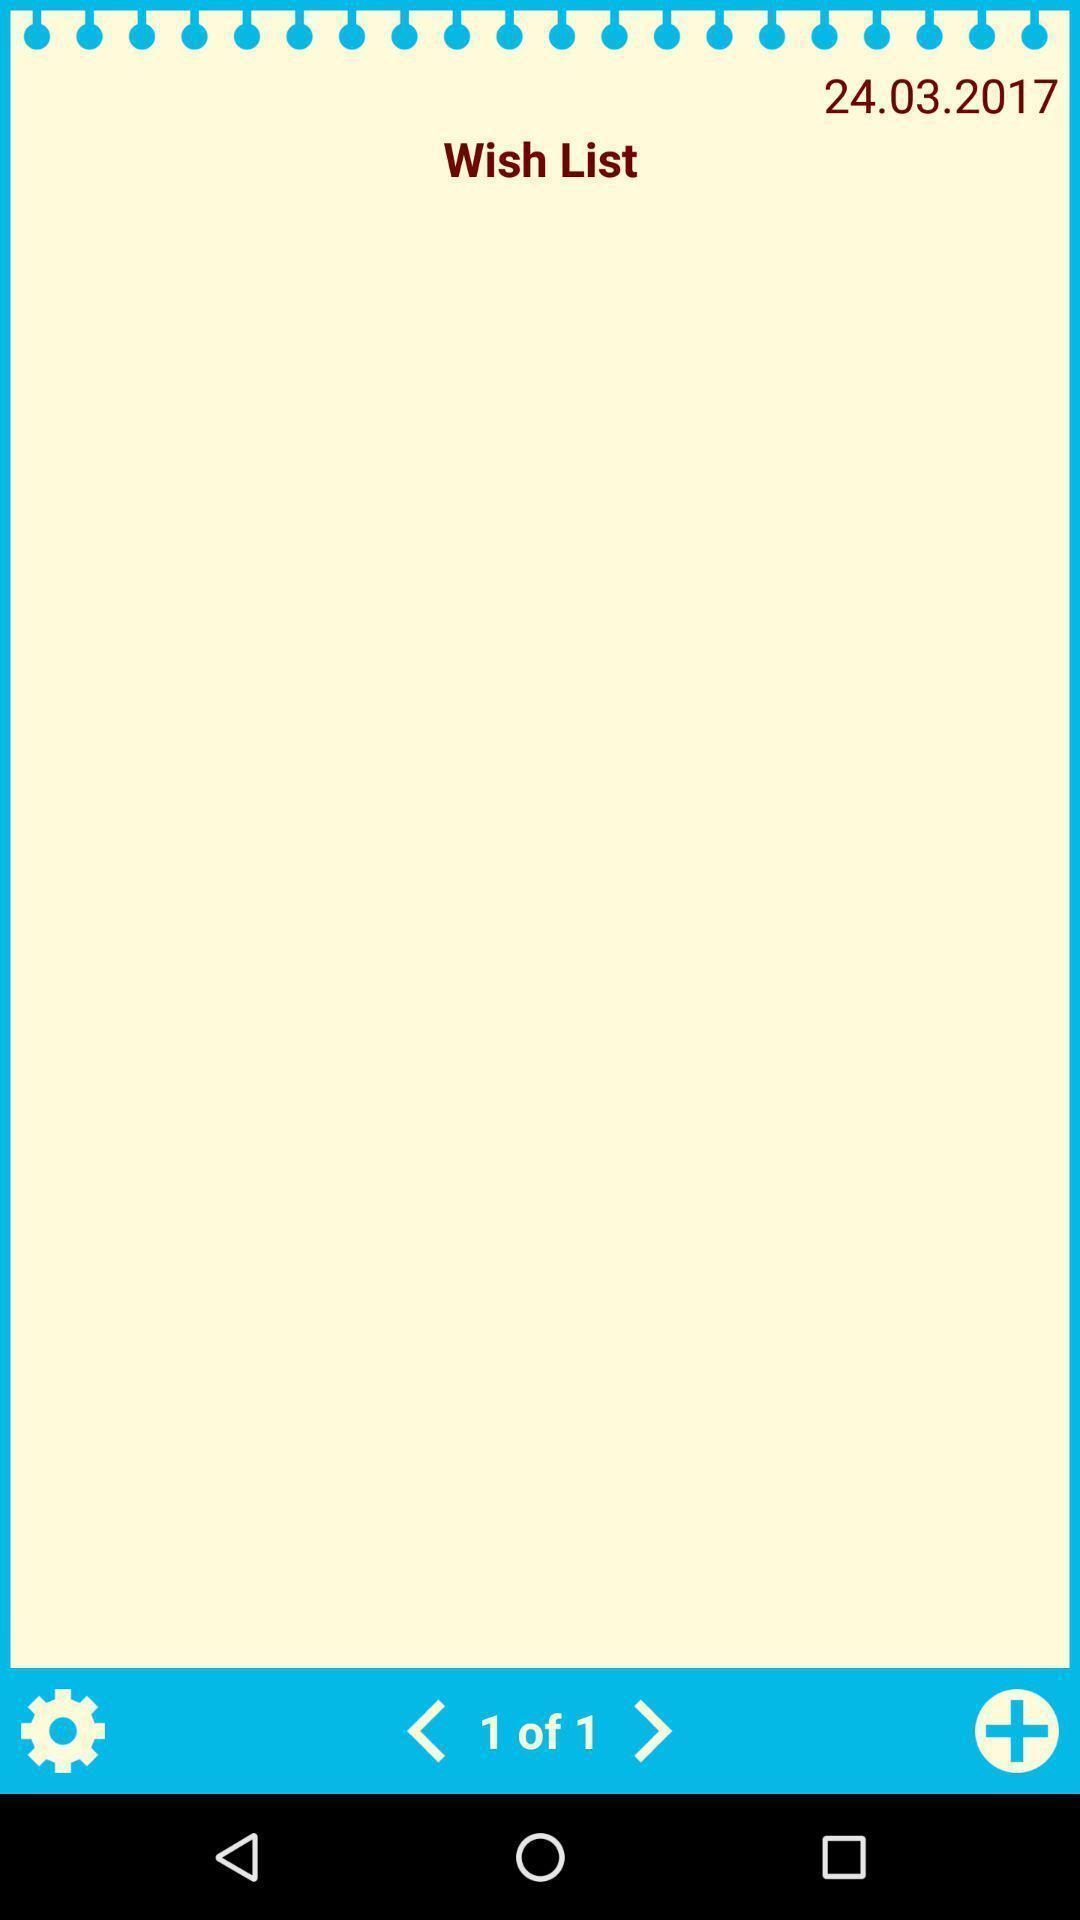Summarize the main components in this picture. Wish list of a particular date. 